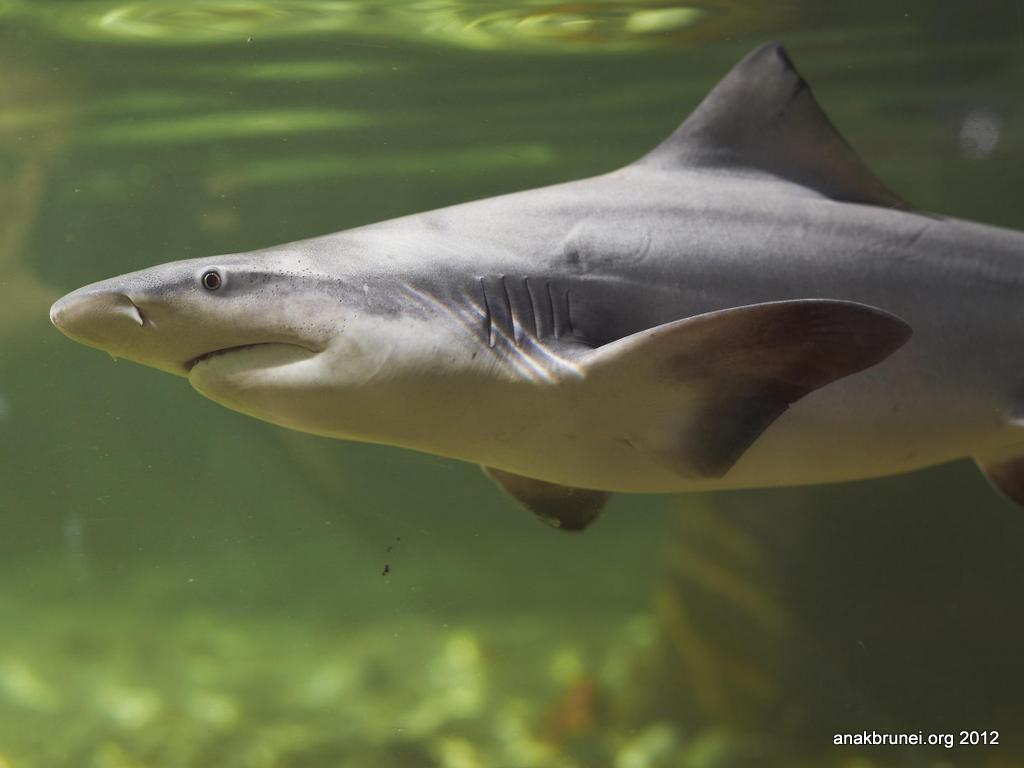What is present in the water in the image? There is a fish in the water. Can you describe the background of the image? The background of the image is blurred. Is there any additional information or branding present in the image? Yes, there is a watermark at the bottom right side of the image. What type of lipstick is being applied in the image? There is no lipstick or application of lipstick present in the image; it features a fish in the water. Can you describe the harbor in the image? There is no harbor present in the image; it features a fish in the water with a blurred background. 